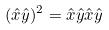<formula> <loc_0><loc_0><loc_500><loc_500>( \hat { x } \hat { y } ) ^ { 2 } = \hat { x } \hat { y } \hat { x } \hat { y }</formula> 